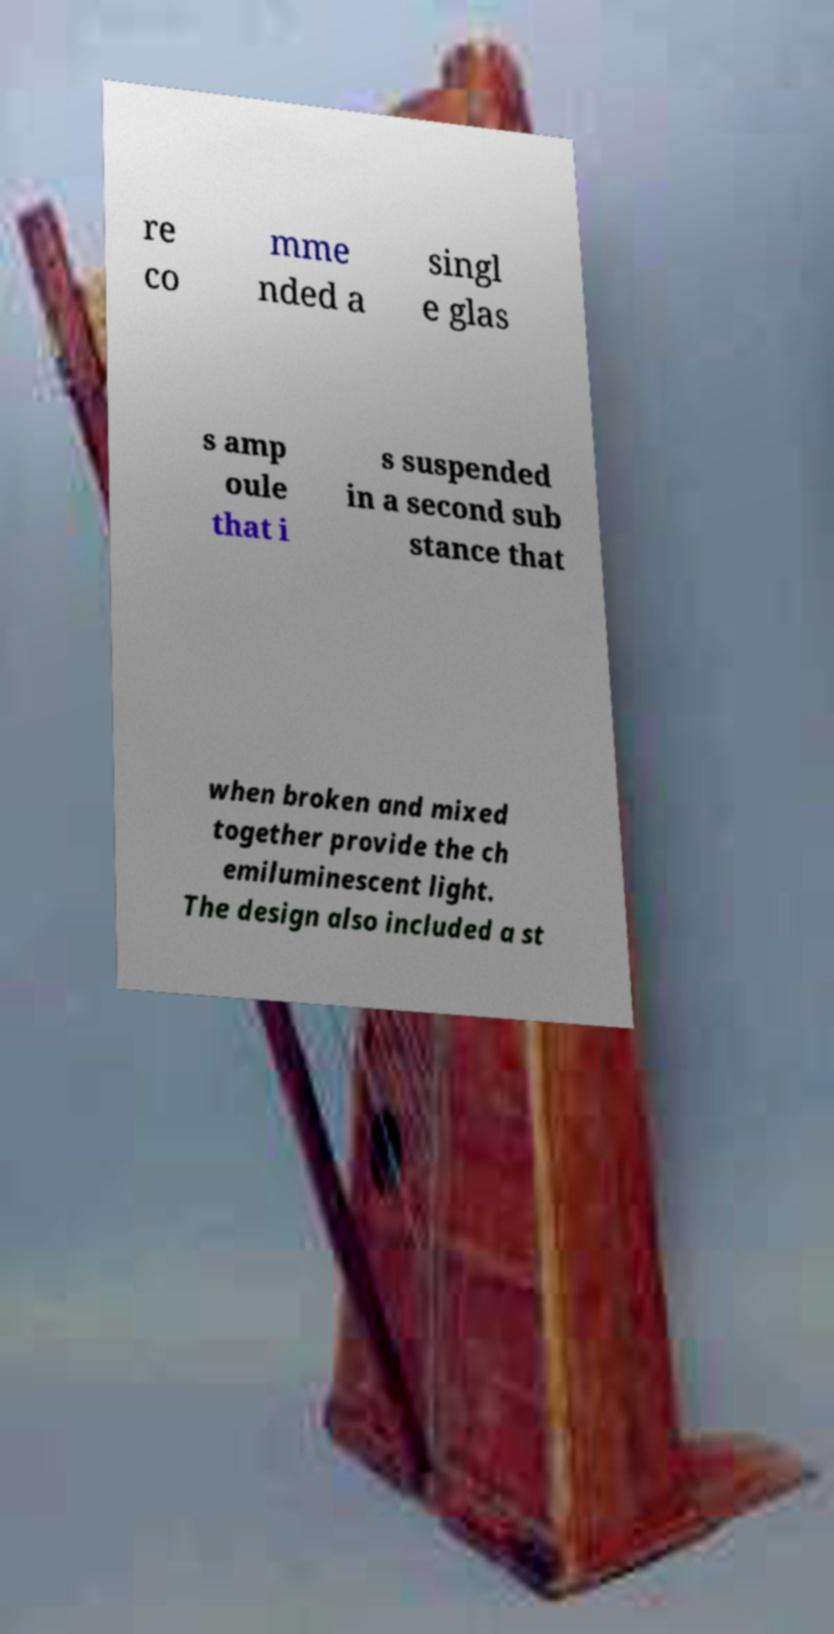Please identify and transcribe the text found in this image. re co mme nded a singl e glas s amp oule that i s suspended in a second sub stance that when broken and mixed together provide the ch emiluminescent light. The design also included a st 